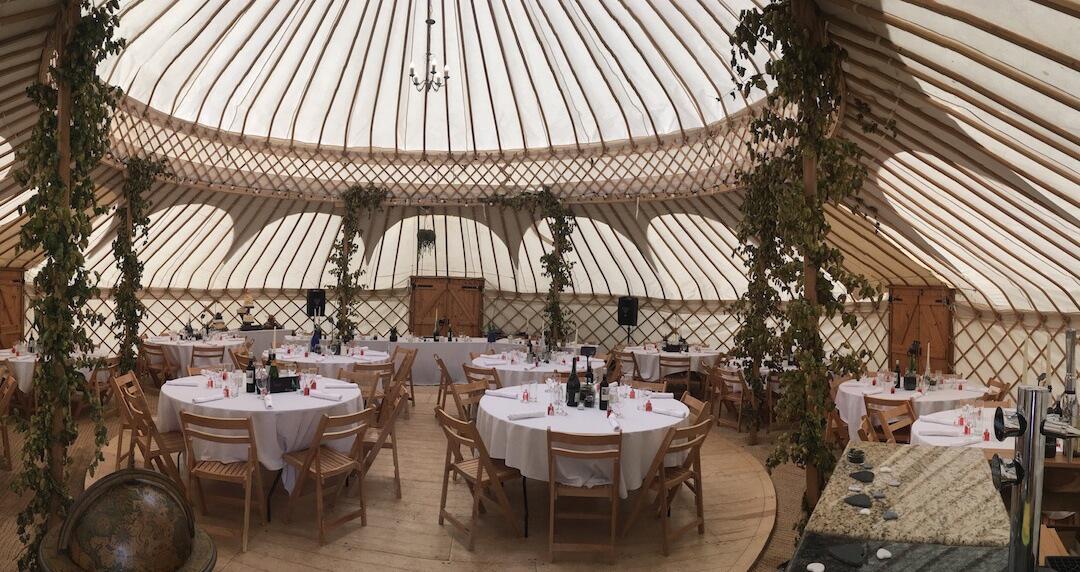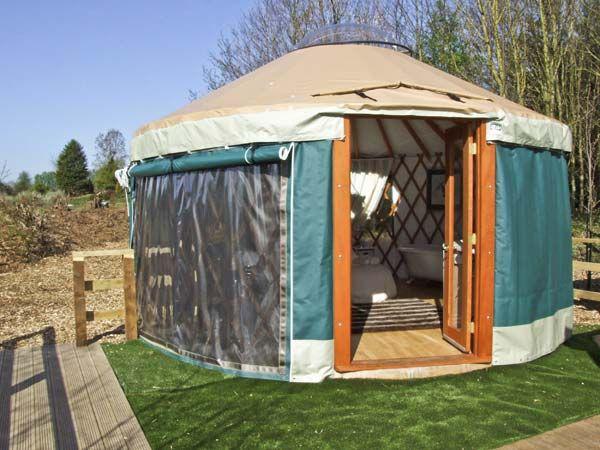The first image is the image on the left, the second image is the image on the right. Assess this claim about the two images: "All images show the outside of a yurt.". Correct or not? Answer yes or no. No. 